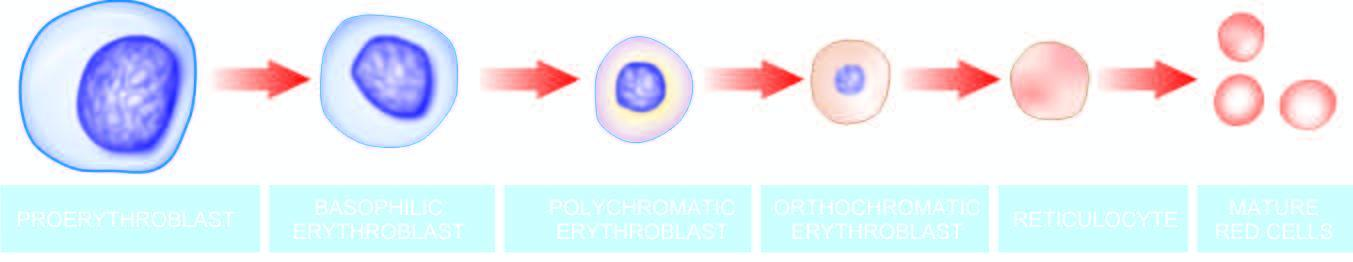does the cytoplasm contain progressively less rna and more haemoglobin?
Answer the question using a single word or phrase. Yes 